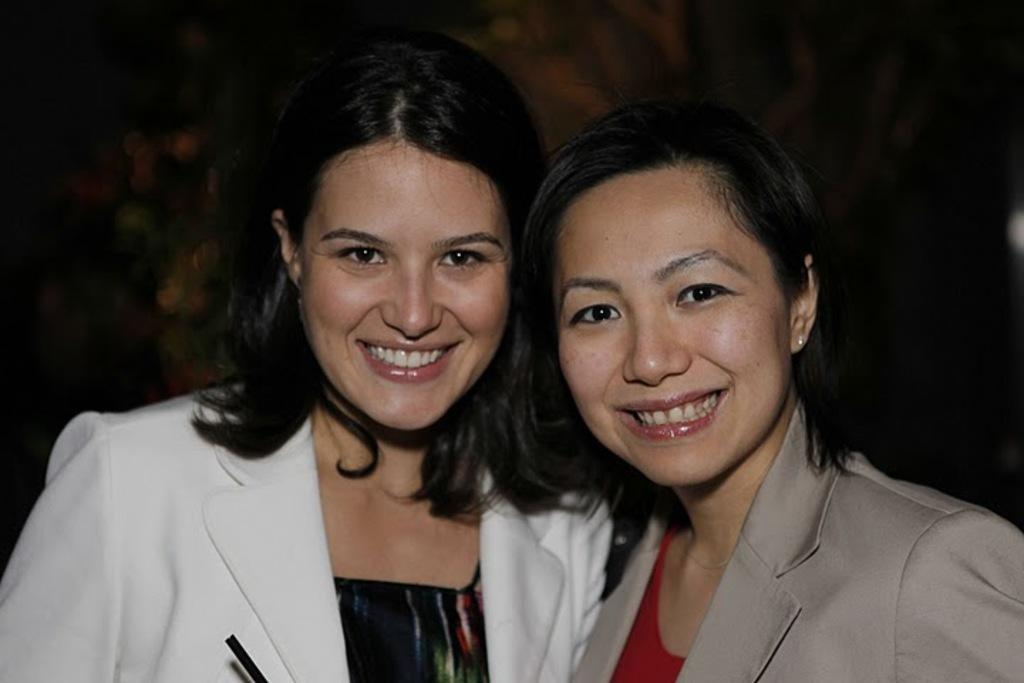How many people are in the image? There are two ladies in the image. Where are the ladies located in the image? The ladies are in the center of the image. What expression do the ladies have in the image? The ladies are smiling in the image. What color are the ladies' toes in the image? There is no information about the ladies' toes in the image, so we cannot determine their color. 